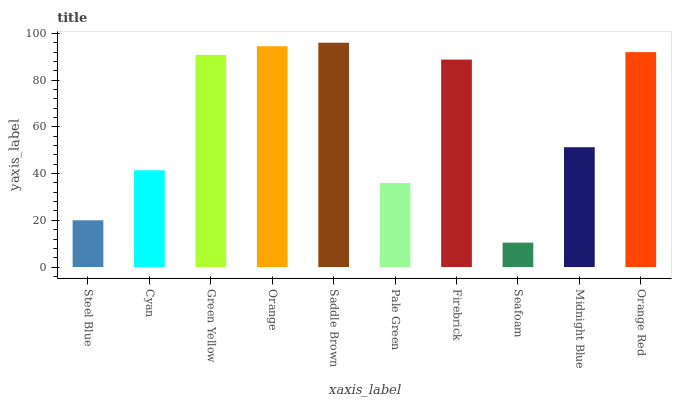Is Seafoam the minimum?
Answer yes or no. Yes. Is Saddle Brown the maximum?
Answer yes or no. Yes. Is Cyan the minimum?
Answer yes or no. No. Is Cyan the maximum?
Answer yes or no. No. Is Cyan greater than Steel Blue?
Answer yes or no. Yes. Is Steel Blue less than Cyan?
Answer yes or no. Yes. Is Steel Blue greater than Cyan?
Answer yes or no. No. Is Cyan less than Steel Blue?
Answer yes or no. No. Is Firebrick the high median?
Answer yes or no. Yes. Is Midnight Blue the low median?
Answer yes or no. Yes. Is Pale Green the high median?
Answer yes or no. No. Is Seafoam the low median?
Answer yes or no. No. 